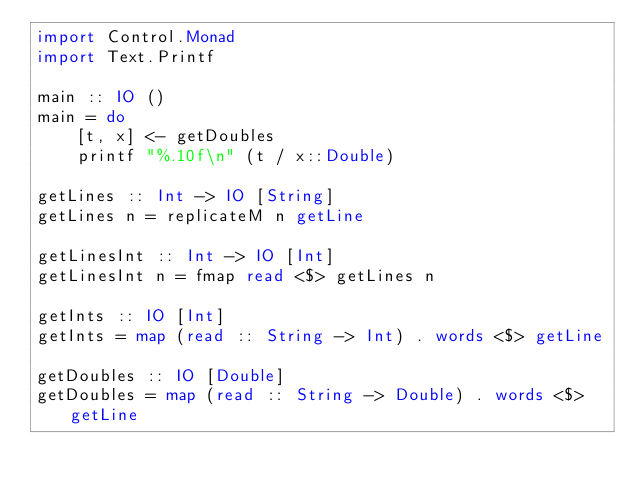Convert code to text. <code><loc_0><loc_0><loc_500><loc_500><_Haskell_>import Control.Monad
import Text.Printf

main :: IO ()
main = do
    [t, x] <- getDoubles
    printf "%.10f\n" (t / x::Double)

getLines :: Int -> IO [String]
getLines n = replicateM n getLine

getLinesInt :: Int -> IO [Int]
getLinesInt n = fmap read <$> getLines n

getInts :: IO [Int]
getInts = map (read :: String -> Int) . words <$> getLine

getDoubles :: IO [Double]
getDoubles = map (read :: String -> Double) . words <$> getLine</code> 